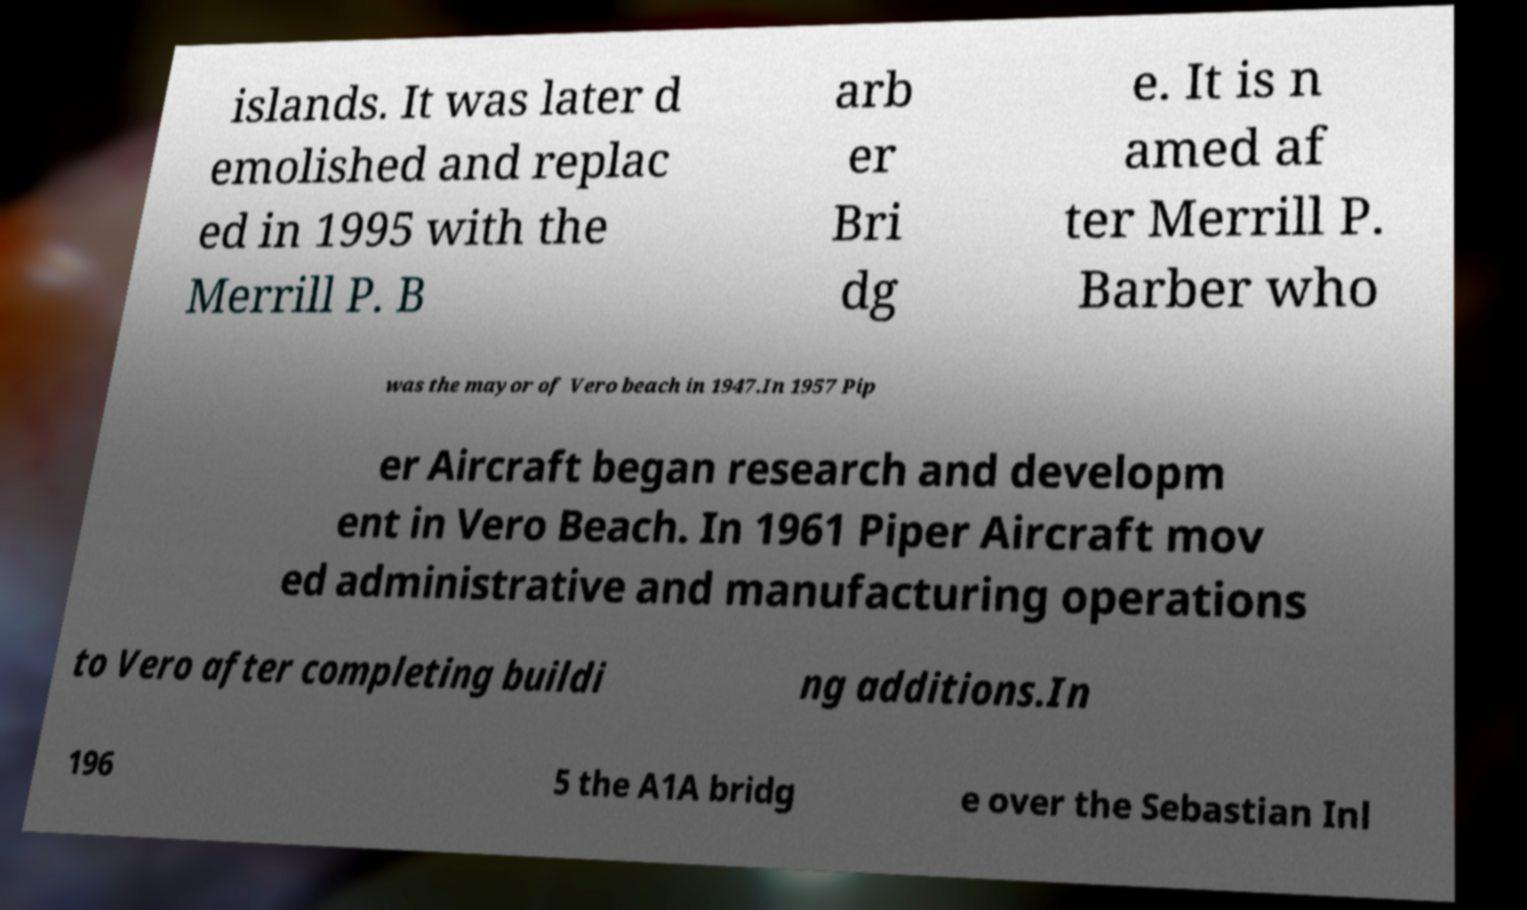Could you extract and type out the text from this image? islands. It was later d emolished and replac ed in 1995 with the Merrill P. B arb er Bri dg e. It is n amed af ter Merrill P. Barber who was the mayor of Vero beach in 1947.In 1957 Pip er Aircraft began research and developm ent in Vero Beach. In 1961 Piper Aircraft mov ed administrative and manufacturing operations to Vero after completing buildi ng additions.In 196 5 the A1A bridg e over the Sebastian Inl 